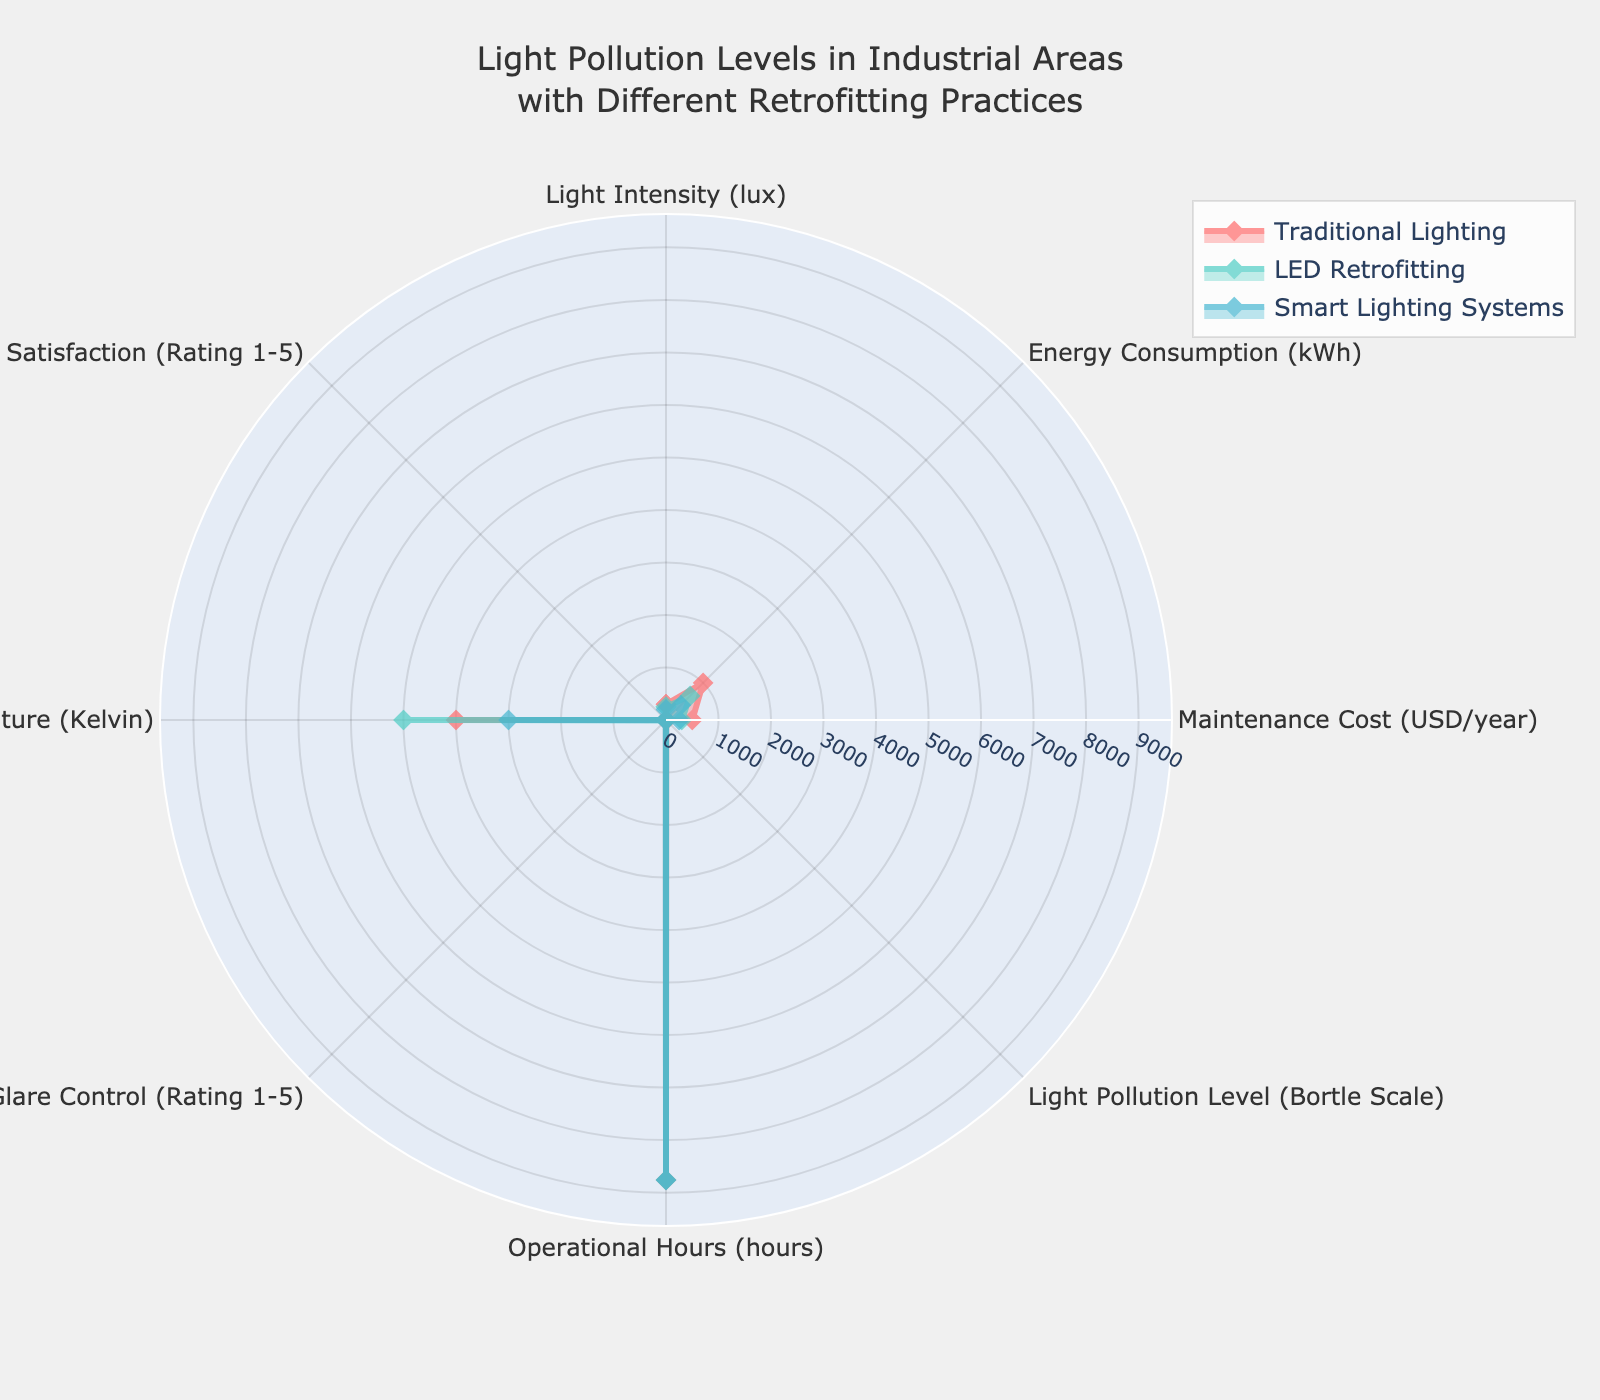What is the title of the figure? The title is displayed at the top of the figure. The text reads "Light Pollution Levels in Industrial Areas with Different Retrofitting Practices."
Answer: Light Pollution Levels in Industrial Areas with Different Retrofitting Practices Which retrofitting practice has the highest User Satisfaction rating? By looking at the "User Satisfaction" axis, the group with the highest value is Smart Lighting Systems, which has a rating of 5.
Answer: Smart Lighting Systems How does the Light Intensity for LED Retrofitting compare to Traditional Lighting? The Light Intensity values for LED Retrofitting and Traditional Lighting are plotted. LED Retrofitting shows an intensity of 250 lux, while Traditional Lighting has 300 lux.
Answer: LED Retrofitting has lower Light Intensity than Traditional Lighting What are the operational hours for all the retrofitting practices? The Operational Hours are the same for all groups. The value shown on the "Operational Hours" axis is 8760 hours for Traditional Lighting, LED Retrofitting, and Smart Lighting Systems.
Answer: 8760 hours What is the difference in Energy Consumption between Traditional Lighting and Smart Lighting Systems? The Energy Consumption for Traditional Lighting is 1000 kWh and for Smart Lighting Systems, it is 400 kWh. Subtract the latter from the former: 1000 - 400.
Answer: 600 kWh Which group has the lowest Light Pollution Level? From the Bortle Scale axis, Smart Lighting Systems has the lowest Light Pollution Level with a value of 2.
Answer: Smart Lighting Systems What is the total Maintenance Cost for Traditional Lighting and LED Retrofitting? The Maintenance Cost for Traditional Lighting is 500 USD/year, and for LED Retrofitting, it is 300 USD/year. Summing them: 500 + 300.
Answer: 800 USD/year How does the Color Temperature for LED Retrofitting compare to Traditional Lighting? The Color Temperature for LED Retrofitting is 5000 K, while for Traditional Lighting, it is 4000 K.
Answer: LED Retrofitting has a higher Color Temperature than Traditional Lighting Which retrofitting practice has the highest Glare Control rating? By viewing the "Glare Control" axis, the group with the highest value is Smart Lighting Systems, which has a rating of 5.
Answer: Smart Lighting Systems What is the average Energy Consumption for all the retrofitting practices? The Energy Consumption values are 1000 kWh for Traditional Lighting, 650 kWh for LED Retrofitting, and 400 kWh for Smart Lighting Systems. Summing these values: 1000 + 650 + 400 = 2050, and then dividing by the number of groups (3): 2050 / 3.
Answer: 683.33 kWh 